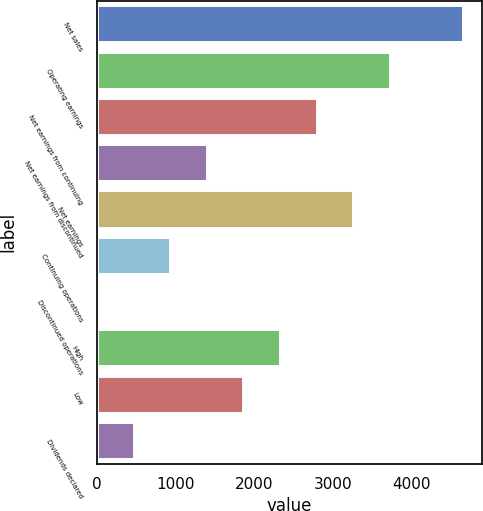Convert chart. <chart><loc_0><loc_0><loc_500><loc_500><bar_chart><fcel>Net sales<fcel>Operating earnings<fcel>Net earnings from continuing<fcel>Net earnings from discontinued<fcel>Net earnings<fcel>Continuing operations<fcel>Discontinued operations<fcel>High<fcel>Low<fcel>Dividends declared<nl><fcel>4661<fcel>3728.83<fcel>2796.63<fcel>1398.33<fcel>3262.73<fcel>932.23<fcel>0.03<fcel>2330.53<fcel>1864.43<fcel>466.13<nl></chart> 